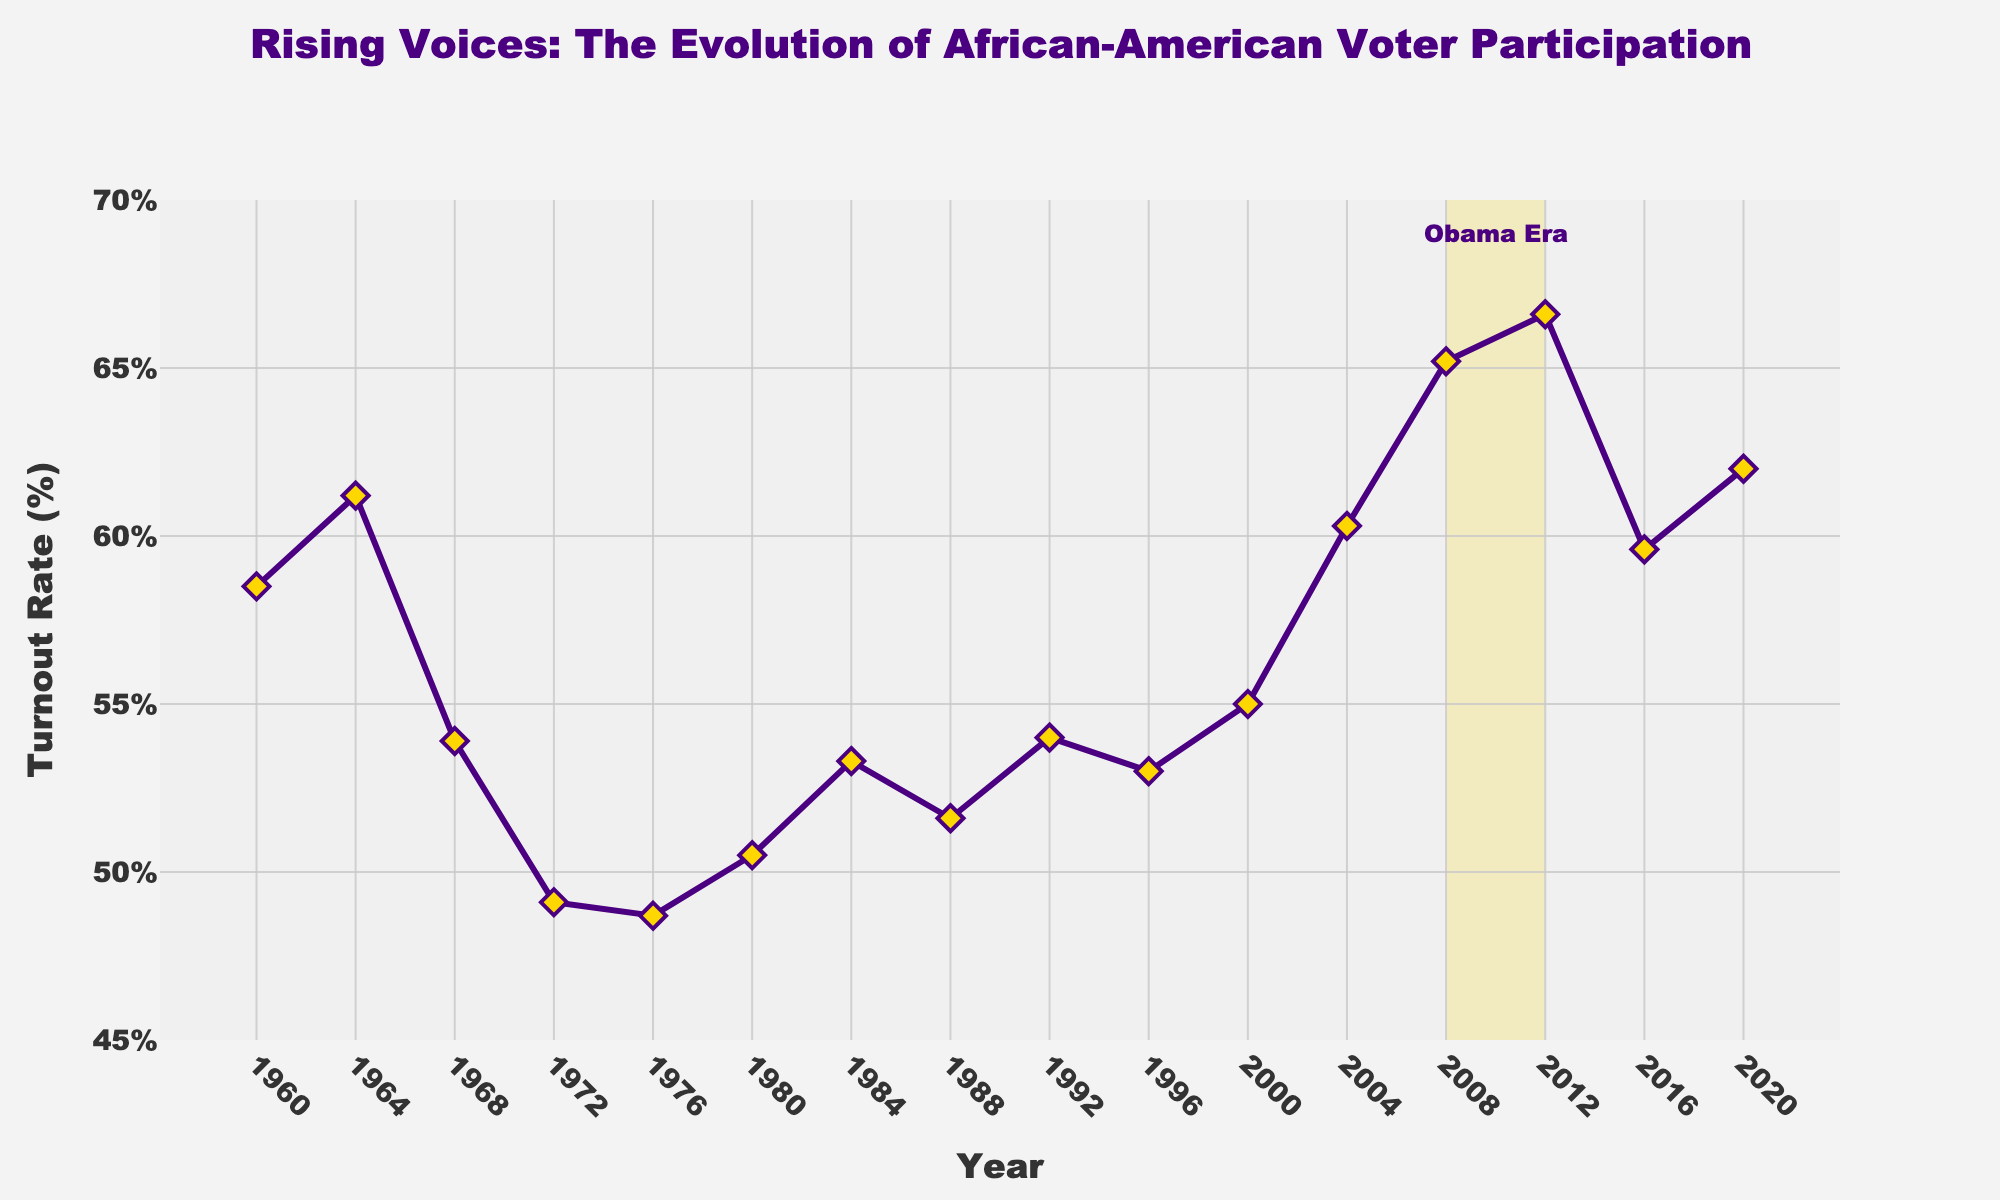What's the title of the figure? The title of the figure is displayed at the top, above the plot area. It reads "African-American Voter Turnout in U.S. Presidential Elections (1960-2020)"
Answer: African-American Voter Turnout in U.S. Presidential Elections (1960-2020) How many data points are shown in the figure? The x-axis shows years from 1960 to 2020 with data points at intervals corresponding to the election years. Counting these intervals, there are 16 data points.
Answer: 16 What is the highest voter turnout rate and in which year did it occur? By looking at the plot, the peak turnout rate is achieved when the line plot reaches its highest point. This occurs in 2012 with a turnout rate of 66.6%.
Answer: 66.6% in 2012 Which year shows the lowest voter turnout rate in the dataset? The lowest point on the line plot can be observed, which corresponds to the year 1976 with a turnout rate of 48.7%.
Answer: 48.7% in 1976 During which period did the "Obama Era" take place, and what shading was used to highlight it? The "Obama Era" is annotated and highlighted by a shaded area from 2008 to 2012 with a gold fill color (yellow).
Answer: 2008-2012, gold shading What's the change in voter turnout rate from 2004 to 2008? The voter turnout rate in 2004 is 60.3%, and in 2008 it is 65.2%. The change is computed by subtracting the 2004 value from the 2008 value, 65.2% - 60.3% = 4.9%.
Answer: 4.9% What is the average voter turnout rate from 2000 to 2020? To find the average, sum the turnout rates for 2000, 2004, 2008, 2012, 2016, and 2020, then divide by the number of data points: (55.0 + 60.3 + 65.2 + 66.6 + 59.6 + 62.0) / 6 = 368.7 / 6 ≈ 61.45%.
Answer: 61.45% What years had a turnout rate above 60%? Identify the years where the turnout rate exceeds 60% by looking at the y-axis values. The years are 1964, 2004, 2008, 2012, and 2020.
Answer: 1964, 2004, 2008, 2012, 2020 How did the voter turnout rate change between 1972 and 1976? The plot shows a drop in voter turnout from 1972 (49.1%) to 1976 (48.7%), with the change computed as 49.1% - 48.7% = 0.4%.
Answer: Decreased by 0.4% What was the voter turnout rate trend from 1960 to 1980? Observe the line plot from 1960 (58.5%) to 1980 (50.5%). The general trend is a decrease in voter turnout over these years.
Answer: Decreasing trend 